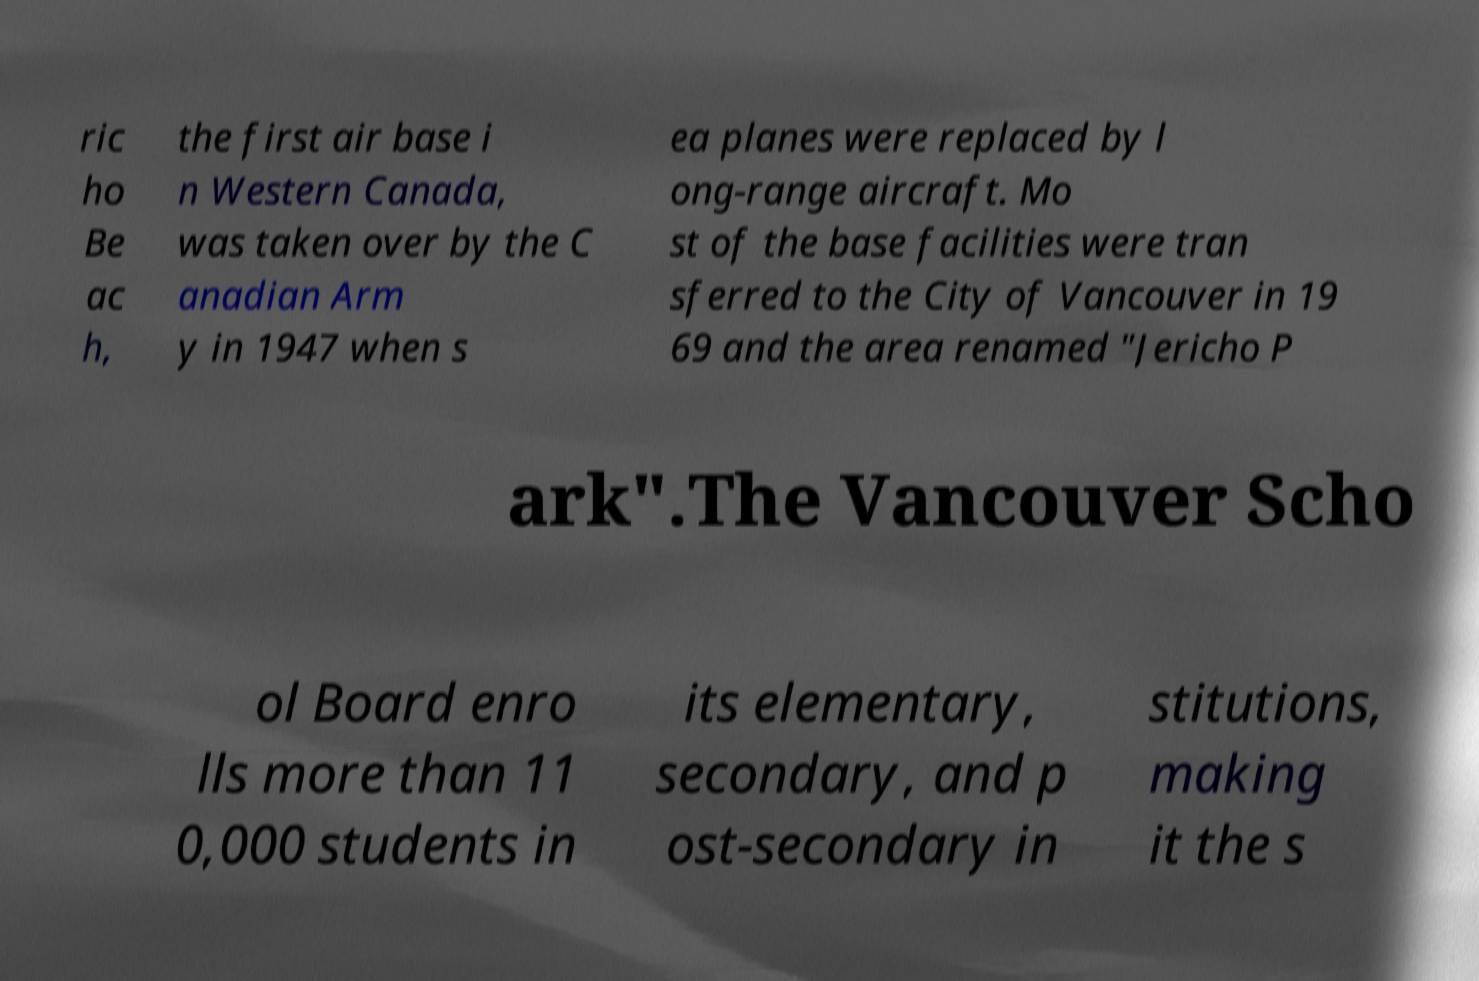I need the written content from this picture converted into text. Can you do that? ric ho Be ac h, the first air base i n Western Canada, was taken over by the C anadian Arm y in 1947 when s ea planes were replaced by l ong-range aircraft. Mo st of the base facilities were tran sferred to the City of Vancouver in 19 69 and the area renamed "Jericho P ark".The Vancouver Scho ol Board enro lls more than 11 0,000 students in its elementary, secondary, and p ost-secondary in stitutions, making it the s 